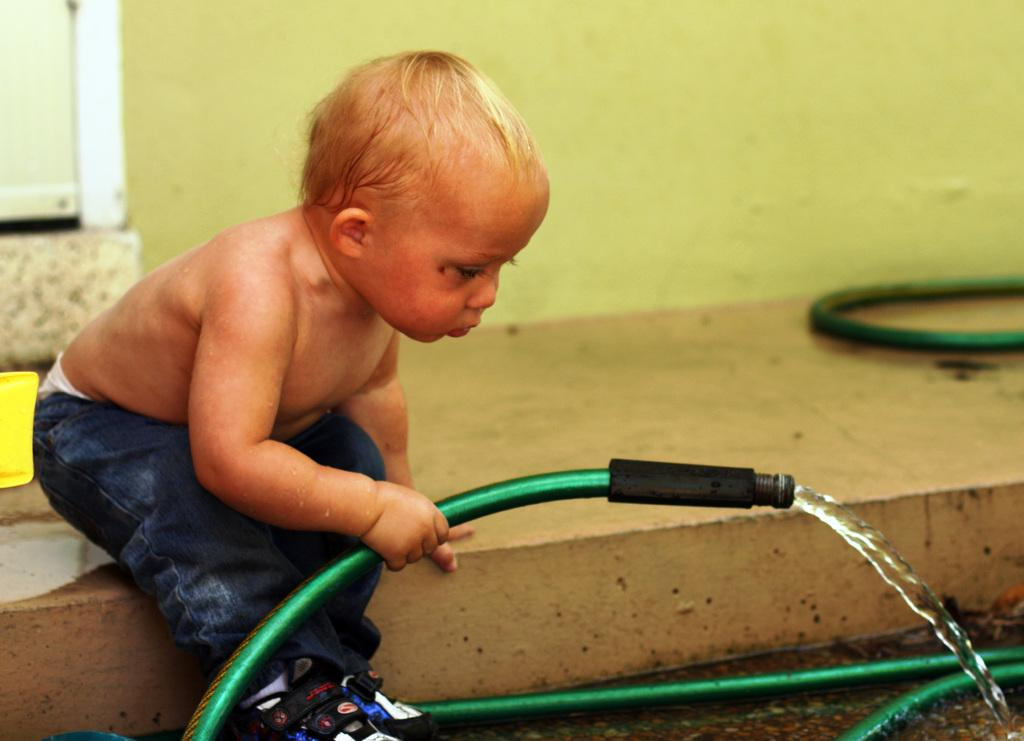Who is present in the image? There is a boy in the image. What is the boy wearing? The boy is wearing jeans. What is the boy doing in the image? The boy is sitting on the floor. What object is the boy holding in his hand? The boy is holding a green color pipe in his hand. What can be seen in the background of the image? There is a wall with a white door in the background. What type of bubble can be seen floating near the boy in the image? There is no bubble present in the image; it only features a boy sitting on the floor holding a green color pipe. 